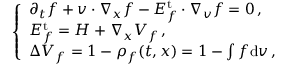<formula> <loc_0><loc_0><loc_500><loc_500>\left \{ \begin{array} { l l } { \partial _ { t } f + v \cdot \nabla _ { x } f - E _ { f } ^ { t } \cdot \nabla _ { v } f = 0 \, , } \\ { E _ { f } ^ { t } = H + \nabla _ { x } V _ { f } \, , } \\ { \Delta V _ { f } = 1 - \rho _ { f } ( t , x ) = 1 - \int f d { v } \, , } \end{array}</formula> 